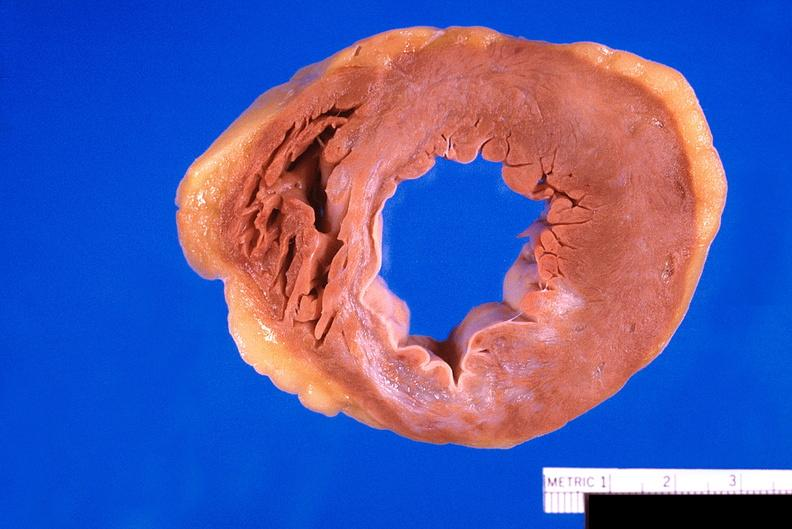s newborn cord around neck present?
Answer the question using a single word or phrase. No 